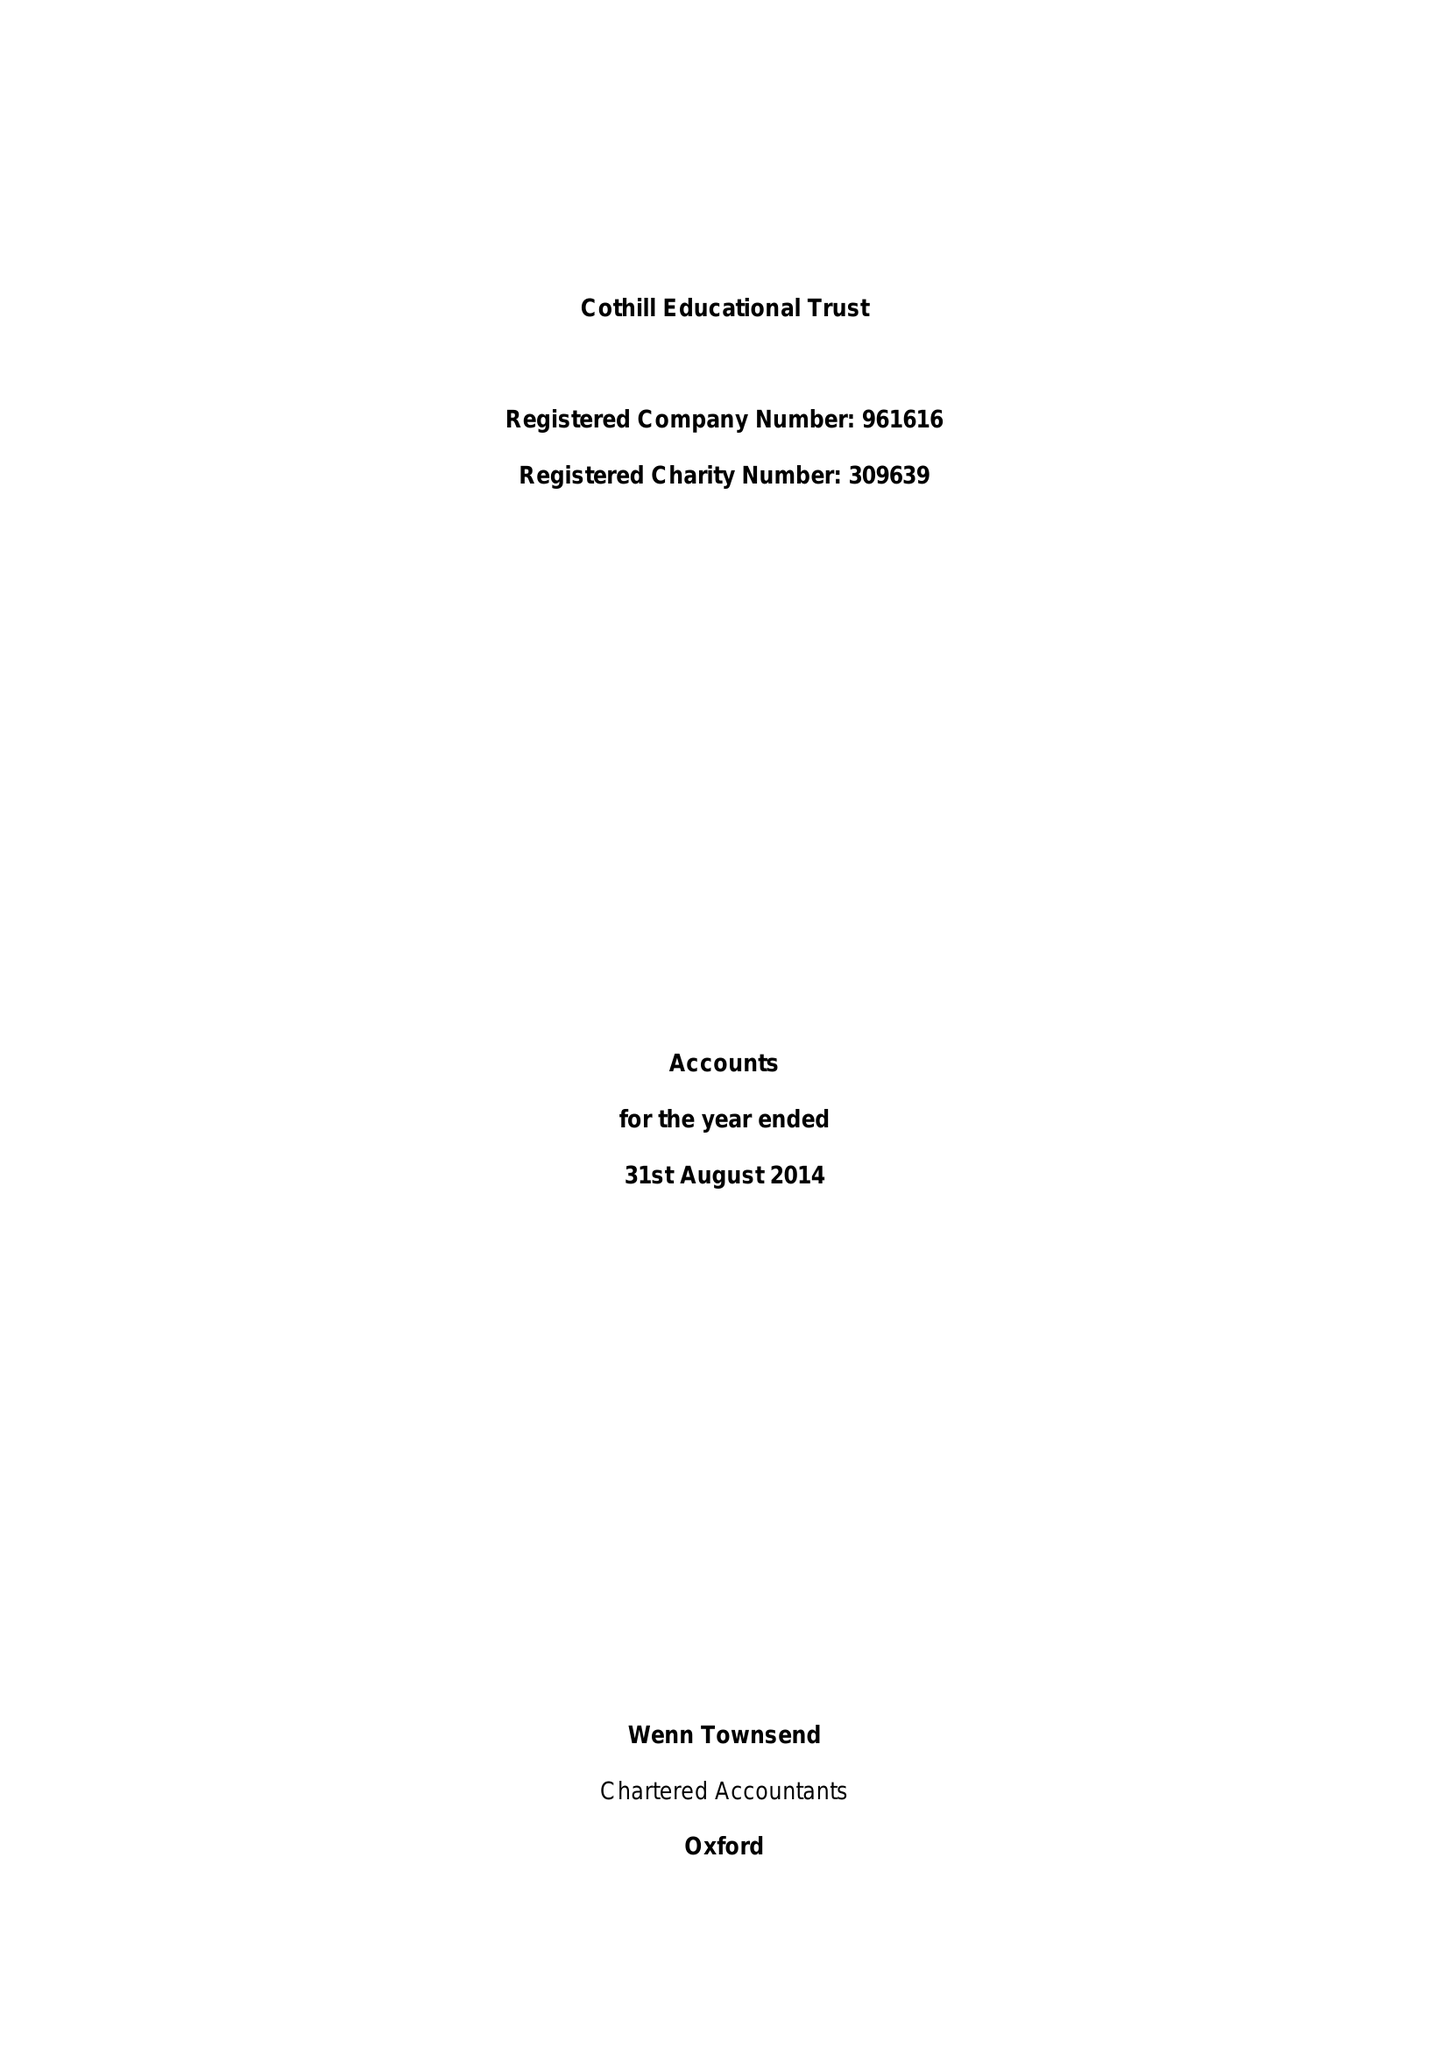What is the value for the spending_annually_in_british_pounds?
Answer the question using a single word or phrase. 17872374.00 